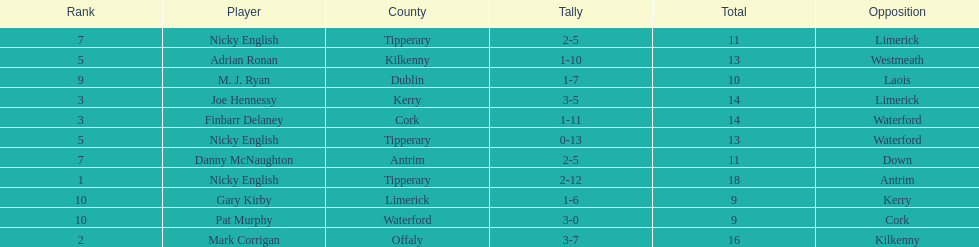Who managed to get 10 cumulative points in their game? M. J. Ryan. 